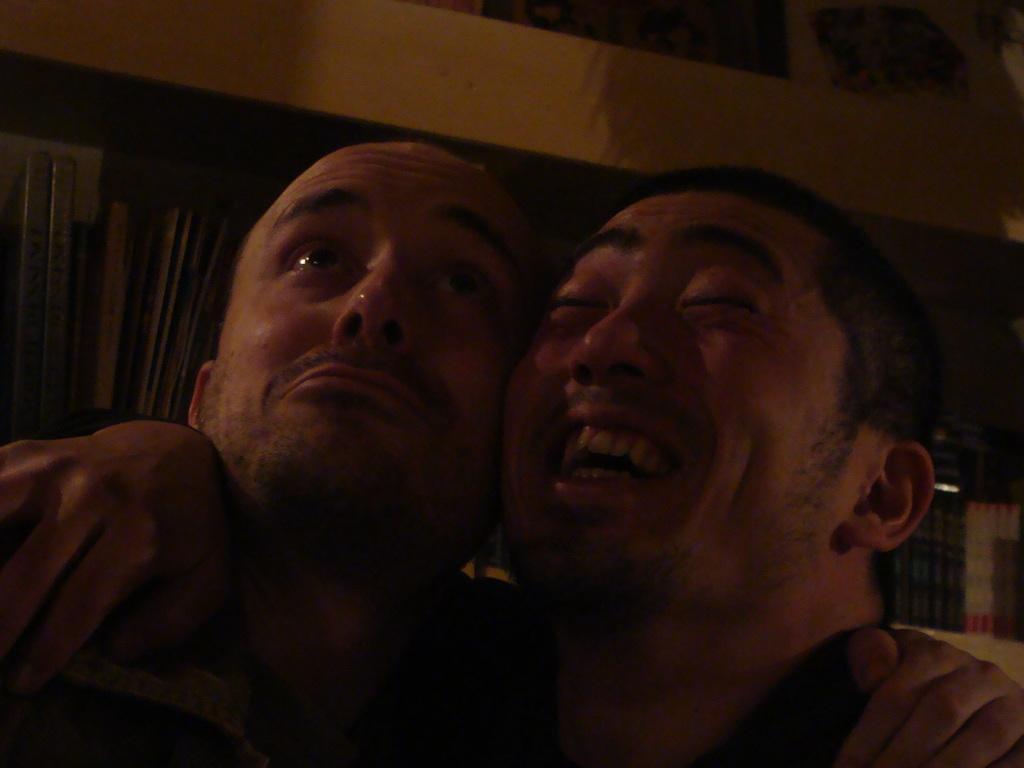Please provide a concise description of this image. In this picture, we can see two persons, and we can see the background. 